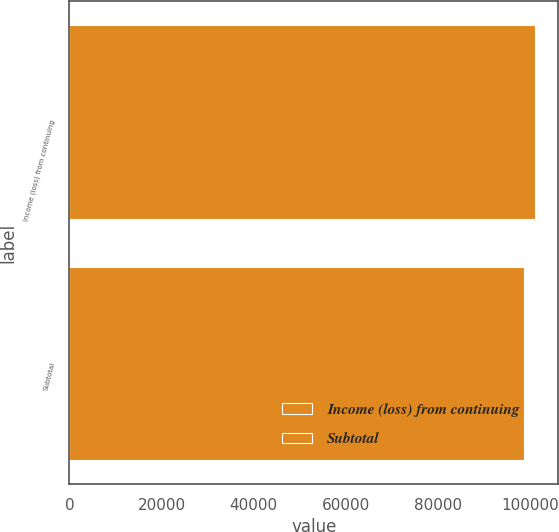Convert chart to OTSL. <chart><loc_0><loc_0><loc_500><loc_500><bar_chart><fcel>Income (loss) from continuing<fcel>Subtotal<nl><fcel>101043<fcel>98675<nl></chart> 